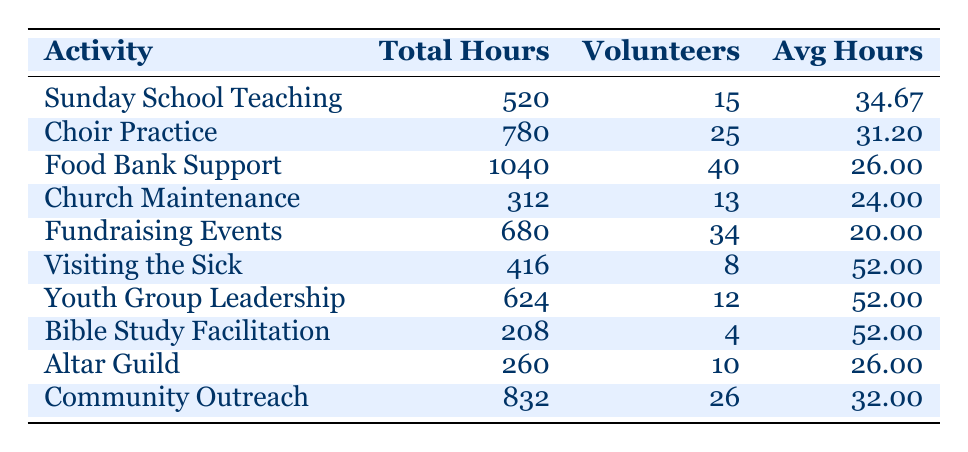What activity received the most total volunteer hours? From the table, we can directly look at the "Total Volunteer Hours" column. The highest number in that column is 1040, which corresponds to "Food Bank Support."
Answer: Food Bank Support How many volunteers contributed to the Choir Practice? We can refer to the "Number of Volunteers" column for Choir Practice, where we see the value is 25.
Answer: 25 What is the average number of hours volunteered per person for Church Maintenance? To find this, we look at the "Average Hours per Volunteer" column for Church Maintenance, which shows a value of 24.00.
Answer: 24.00 Did more volunteers contribute to Community Outreach than to Youth Group Leadership? We compare the "Number of Volunteers" for both activities. Community Outreach has 26 volunteers and Youth Group Leadership has 12. Since 26 is greater than 12, the answer is yes.
Answer: Yes What is the sum of total volunteer hours for all activities? We sum the total hours from the "Total Volunteer Hours" column: 520 + 780 + 1040 + 312 + 680 + 416 + 624 + 208 + 260 + 832 = 4680.
Answer: 4680 Is the average number of hours volunteered per person in Sunday School Teaching higher than in Fundraising Events? We check the "Average Hours per Volunteer" for both activities. Sunday School Teaching has 34.67 hours, while Fundraising Events has 20.00 hours. Since 34.67 is greater than 20.00, the answer is yes.
Answer: Yes What is the median number of volunteers across all activities? First, we list the number of volunteers: 15, 25, 40, 13, 34, 8, 12, 4, 10, and 26. When arranged in order, the sorted list is: 4, 8, 10, 12, 13, 15, 25, 26, 34, 40. With 10 numbers, the median will be the average of the 5th and 6th values: (13 + 15) / 2 = 14.
Answer: 14 Which activity had the highest average hours worked per volunteer? We look at the "Average Hours per Volunteer" column. The highest value is 52.00 hours, which corresponds to three activities: Visiting the Sick, Youth Group Leadership, and Bible Study Facilitation.
Answer: Visiting the Sick, Youth Group Leadership, Bible Study Facilitation What percentage of the total volunteer hours came from Food Bank Support? First, we found that the total volunteer hours are 4680. Food Bank Support contributed 1040 hours. To find the percentage: (1040 / 4680) * 100 ≈ 22.23%.
Answer: 22.23% 